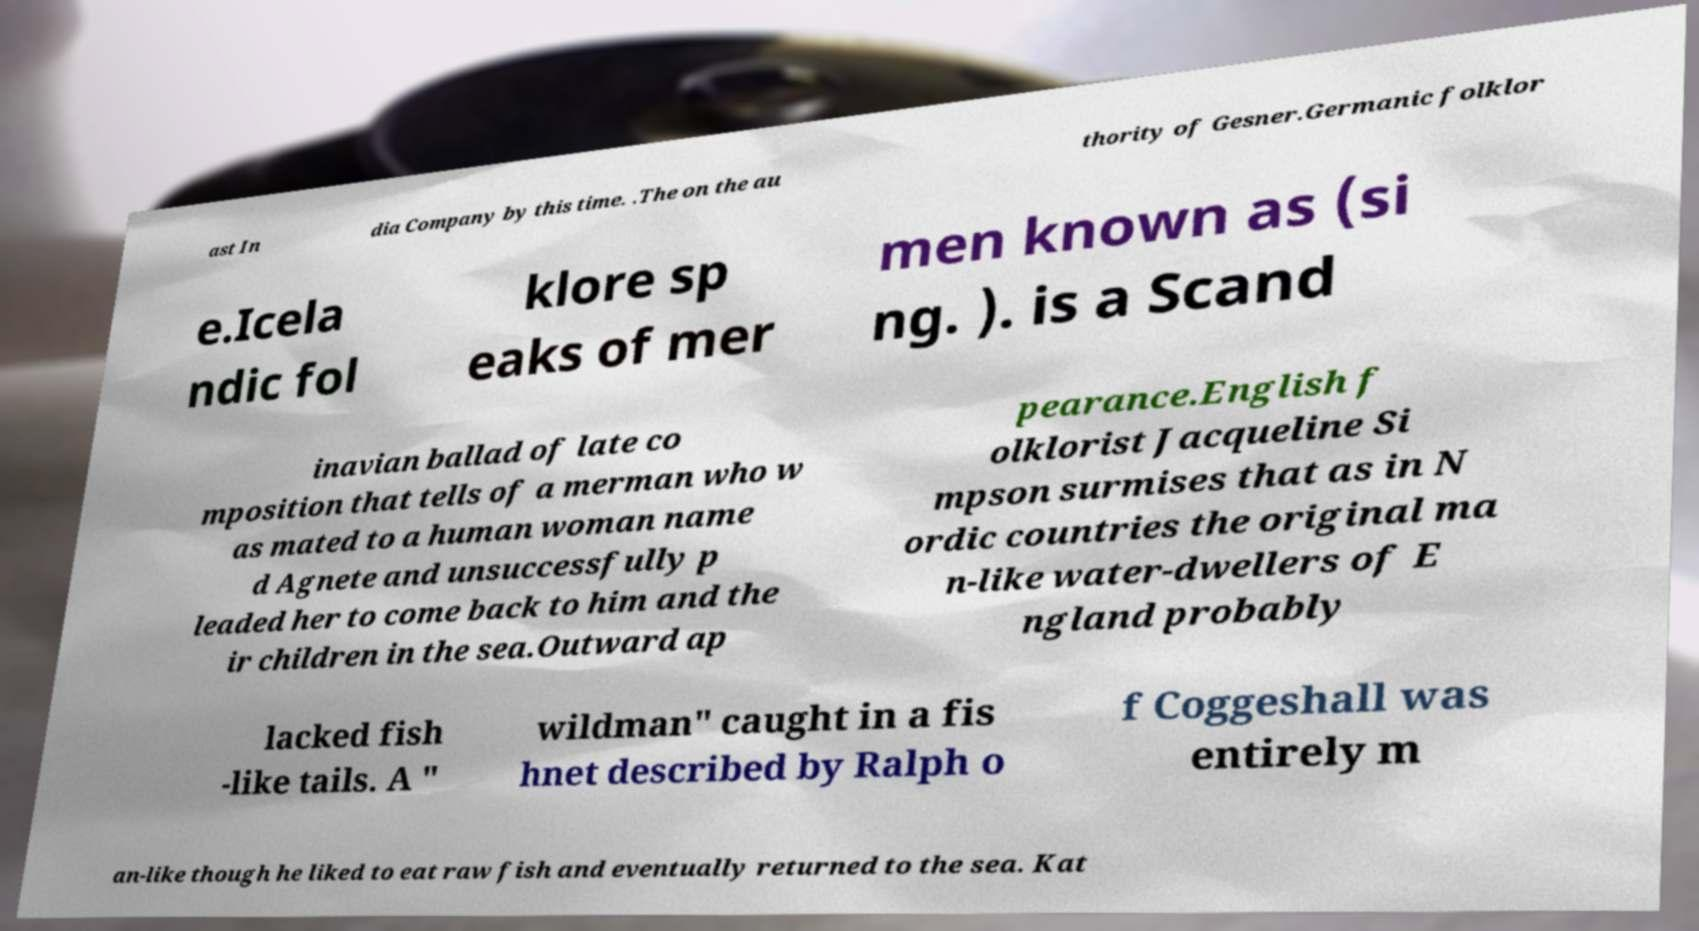Can you accurately transcribe the text from the provided image for me? ast In dia Company by this time. .The on the au thority of Gesner.Germanic folklor e.Icela ndic fol klore sp eaks of mer men known as (si ng. ). is a Scand inavian ballad of late co mposition that tells of a merman who w as mated to a human woman name d Agnete and unsuccessfully p leaded her to come back to him and the ir children in the sea.Outward ap pearance.English f olklorist Jacqueline Si mpson surmises that as in N ordic countries the original ma n-like water-dwellers of E ngland probably lacked fish -like tails. A " wildman" caught in a fis hnet described by Ralph o f Coggeshall was entirely m an-like though he liked to eat raw fish and eventually returned to the sea. Kat 